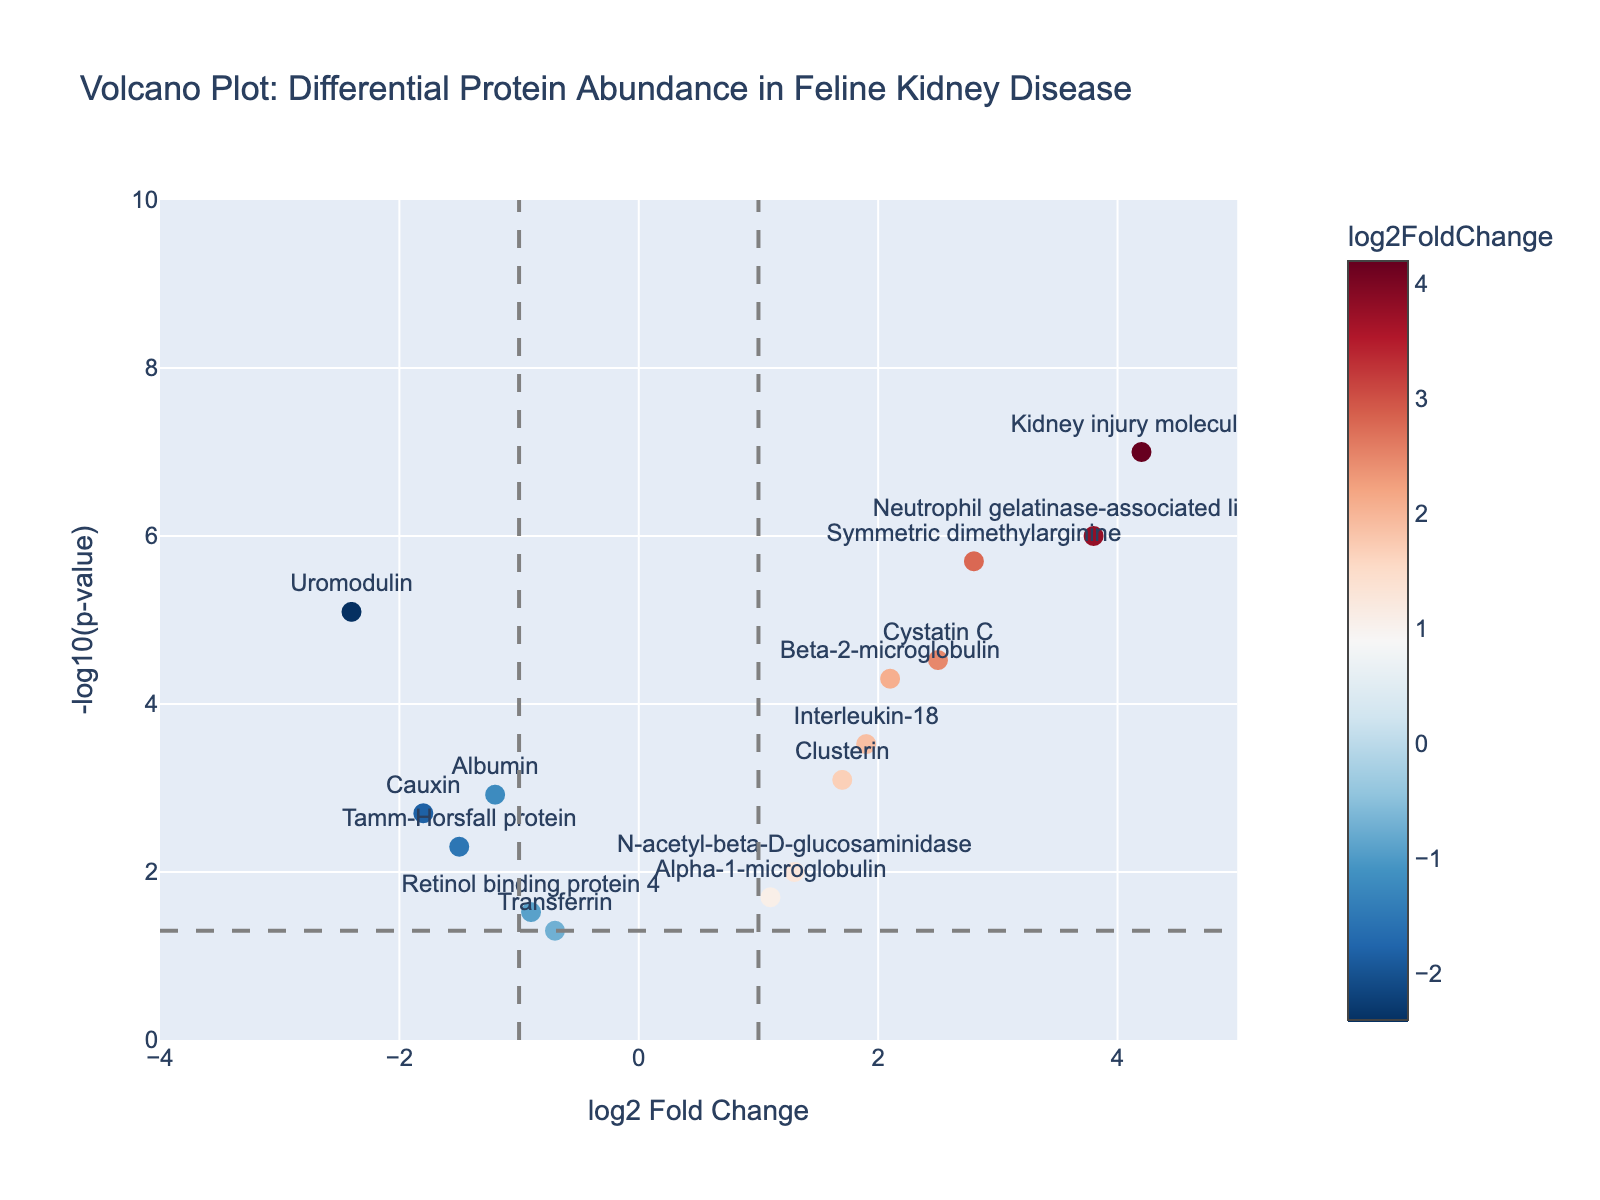What is the title of the plot? The title of the figure is located at the top and usually describes the main content or subject of the plot. Here, it's "Volcano Plot: Differential Protein Abundance in Feline Kidney Disease".
Answer: Volcano Plot: Differential Protein Abundance in Feline Kidney Disease How many proteins have a log2FoldChange greater than 2? To determine how many proteins have a log2FoldChange greater than 2, look at the x-axis values and count the data points that are positioned to the right of 2.
Answer: 5 Which protein shows the most significant change in p-value? The most significant change in p-value will be the protein with the highest -log10(p-value) on the y-axis. This is the data point that is positioned the highest in the plot.
Answer: Kidney Injury Molecule-1 Where are the vertical reference lines located? The vertical reference lines are used to identify thresholds in the x-axis. They are situated at log2FoldChange values of -1 and 1.
Answer: at -1 and 1 on the x-axis How many proteins are significantly upregulated (log2FoldChange > 1 and p-value < 0.05)? To answer this, count the number of data points that have a log2FoldChange greater than 1 and a -log10(p-value) greater than -log10(0.05) (above the horizontal reference line).
Answer: 7 Which protein has the smallest log2FoldChange value? The smallest log2FoldChange value will be the point furthest to the left on the x-axis. This corresponds to the most negative log2FoldChange.
Answer: Uromodulin How many proteins are not significantly differentially expressed (p-value > 0.05)? To determine this, count the number of data points with -log10(p-value) less than -log10(0.05), i.e., below the horizontal reference line.
Answer: 1 Which proteins are colored red and why? The colors are determined by the log2FoldChange values, with red typically indicating positive values (upregulation). Identify proteins with positive log2FoldChange.
Answer: Cystatin C, Neutrophil gelatinase-associated lipocalin, Clusterin, Beta-2-microglobulin, N-acetyl-beta-D-glucosaminidase, Kidney injury molecule-1, Interleukin-18, Symmetric dimethylarginine, Alpha-1-microglobulin What is the log2FoldChange and p-value of Albumin? The log2FoldChange and p-value for Albumin can be derived from its position and the hover text.
Answer: log2FoldChange: -1.2, p-value: 0.0012 Which upregulated protein has the second lowest p-value? Examine the proteins on the right side (log2FoldChange > 0) and determine which has the second highest -log10(p-value). This corresponds to the second smallest p-value.
Answer: Symmetric dimethylarginine 